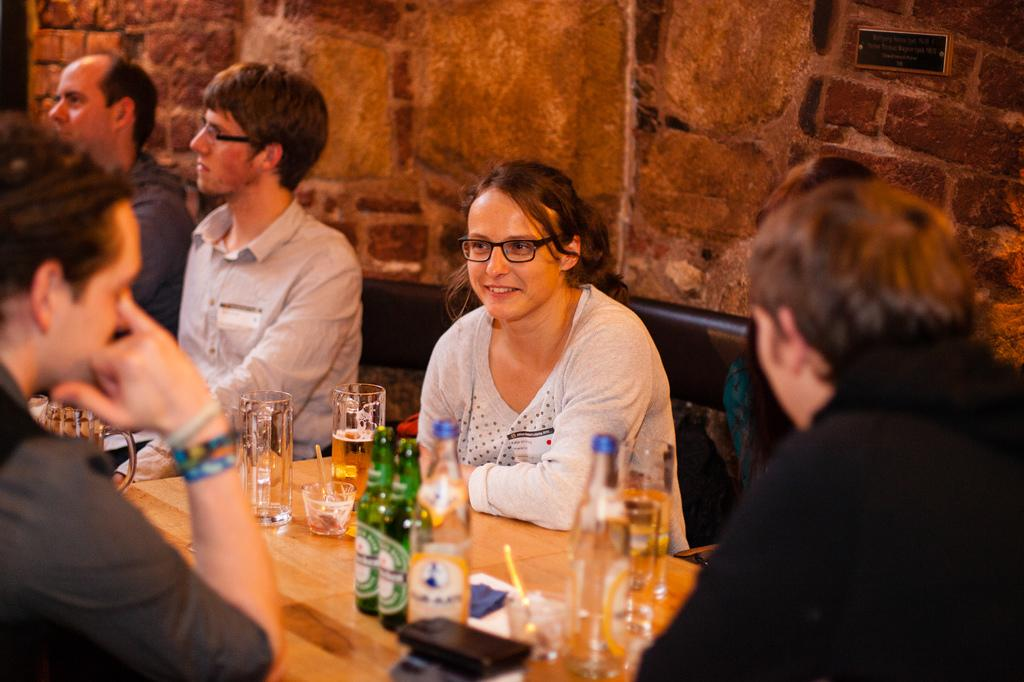What are the people in the image doing? The people in the image are sitting on chairs. What can be seen on the table in the image? There are objects on a table in the image. What is visible in the background of the image? There is a brick wall in the background of the image. What type of rock can be seen in the mine in the image? There is no mine or rock present in the image; it features people sitting on chairs and a brick wall in the background. 